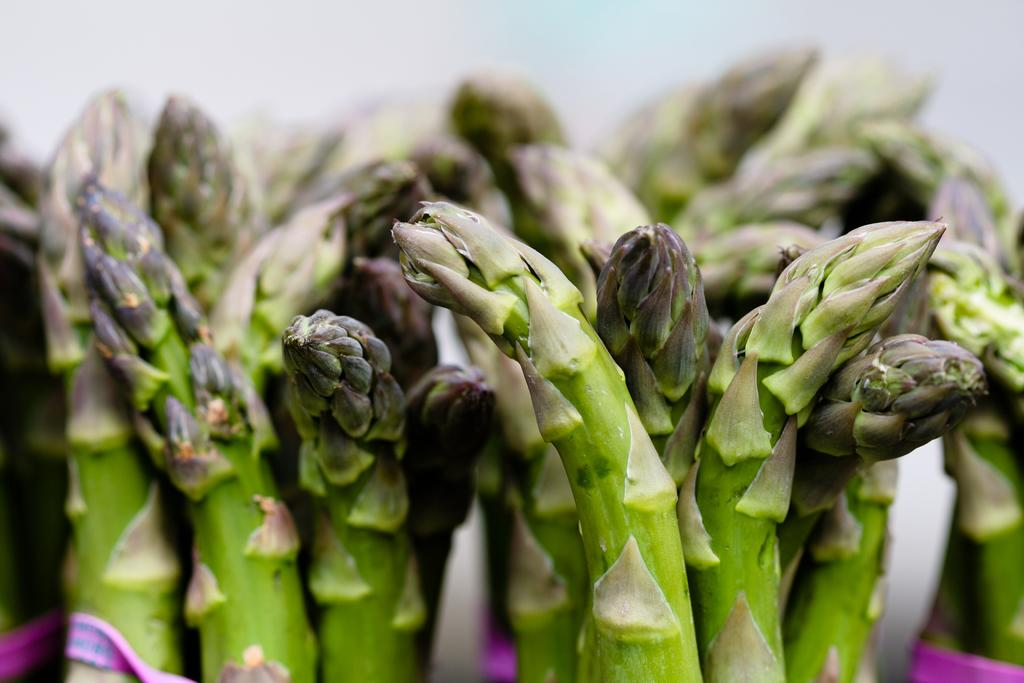What type of living organisms can be seen in the image? Plants can be seen in the image. What is the other object visible in the image? There is a cloth in the image. Can you describe the background of the image? The background of the image is blurry. How many houses can be seen in the image? There are no houses present in the image. What type of heart-shaped object is visible in the image? There is no heart-shaped object present in the image. 